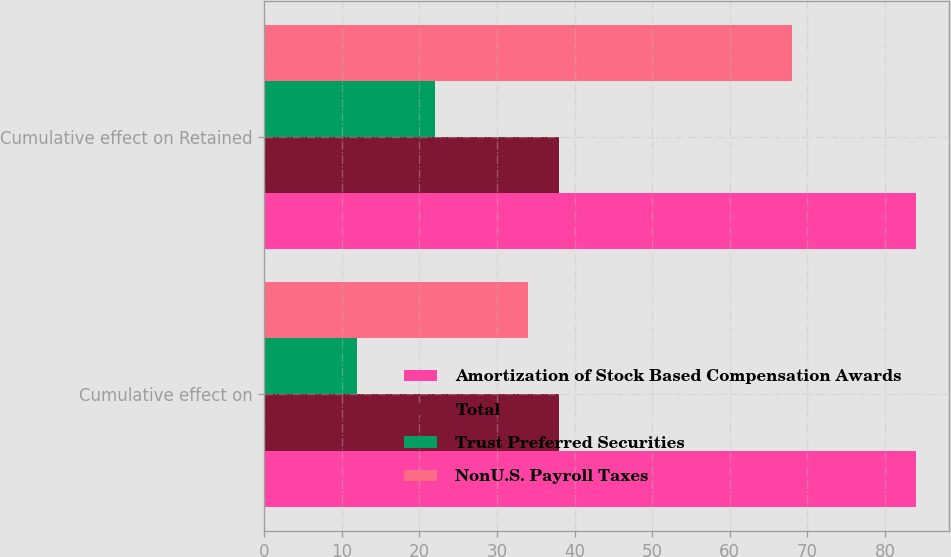<chart> <loc_0><loc_0><loc_500><loc_500><stacked_bar_chart><ecel><fcel>Cumulative effect on<fcel>Cumulative effect on Retained<nl><fcel>Amortization of Stock Based Compensation Awards<fcel>84<fcel>84<nl><fcel>Total<fcel>38<fcel>38<nl><fcel>Trust Preferred Securities<fcel>12<fcel>22<nl><fcel>NonU.S. Payroll Taxes<fcel>34<fcel>68<nl></chart> 